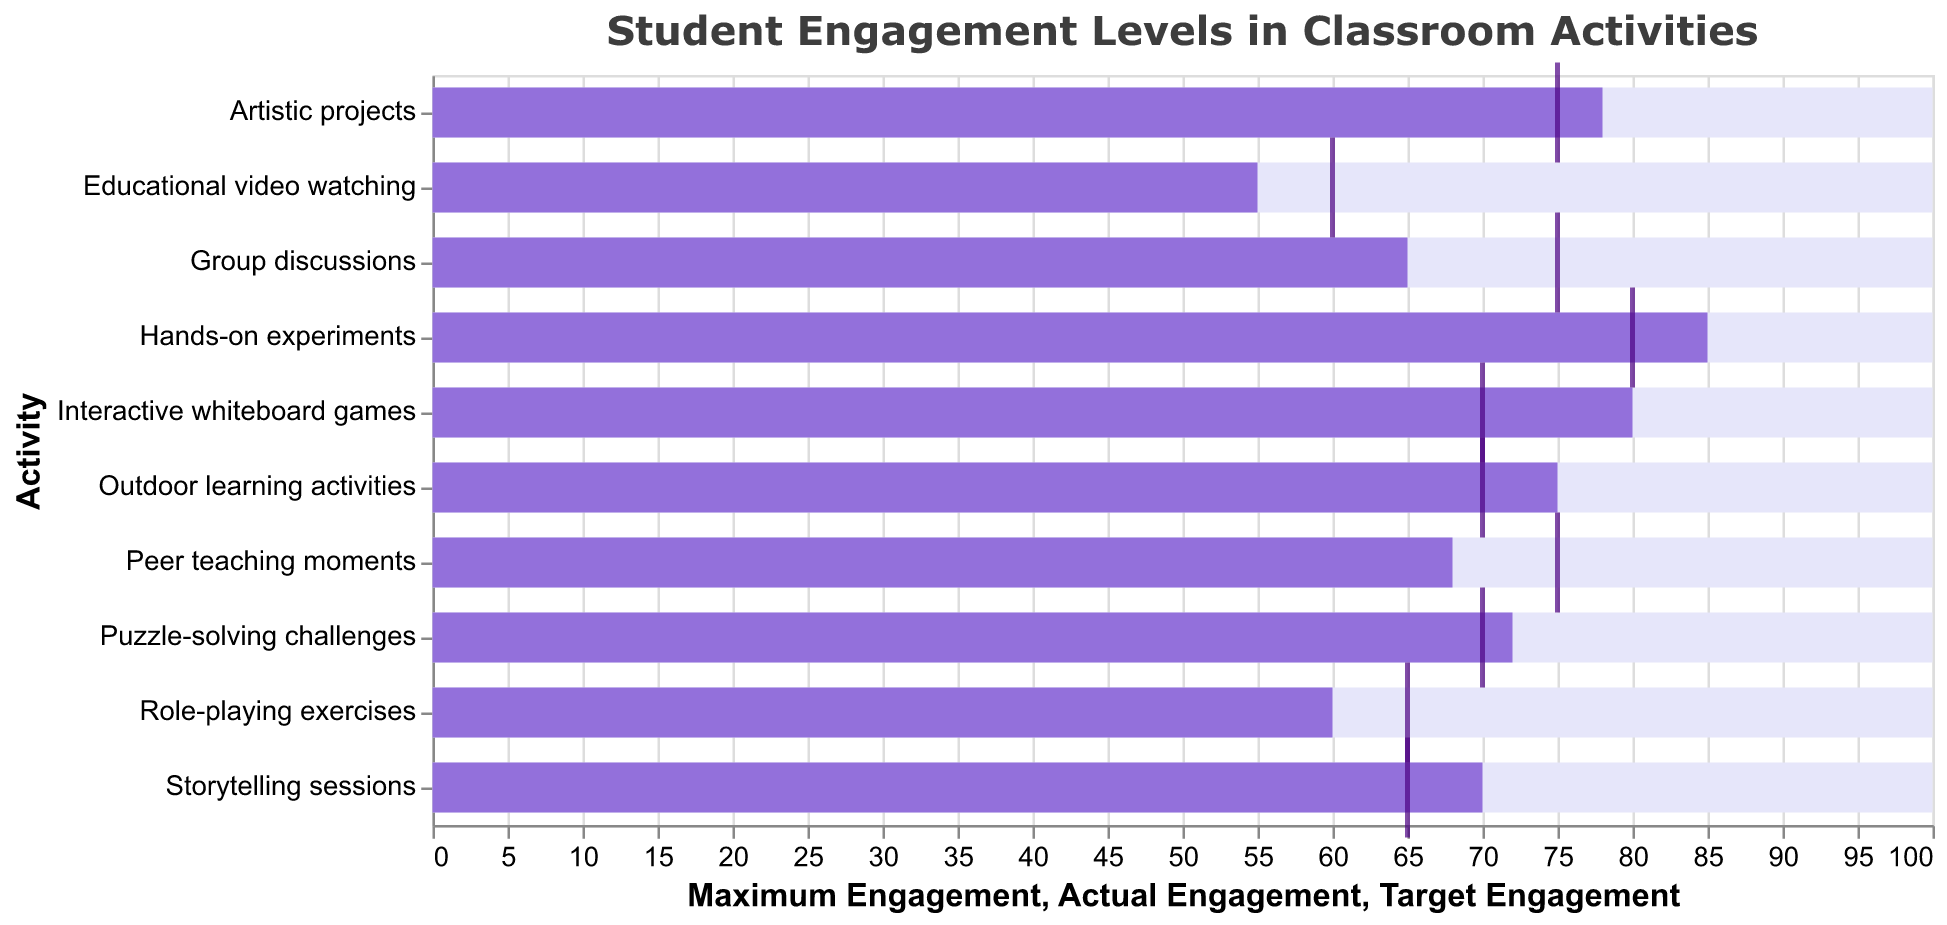What is the title of the bullet chart? The chart title is present at the top of the figure. It reads: "Student Engagement Levels in Classroom Activities".
Answer: Student Engagement Levels in Classroom Activities How many activities have an actual engagement above their target engagement? To answer this, we identify the activities where the bar representing 'Actual Engagement' exceeds the 'Target Engagement' tick mark. They are "Interactive whiteboard games," "Hands-on experiments," "Storytelling sessions," "Outdoor learning activities," "Artistic projects," and "Puzzle-solving challenges."
Answer: Six Which activity has the lowest actual engagement level? By examining the 'Actual Engagement' bar sizing for all activities, we find that "Educational video watching" has the smallest bar, indicating it has the lowest actual engagement level.
Answer: Educational video watching Is there an activity where the actual engagement exactly matches the target engagement? We need to check if any bar (Actual Engagement) is exactly aligned with its respective tick mark (Target Engagement). None of the activities have an exact match.
Answer: No What is the difference between the actual engagement and target engagement for Hands-on experiments? Subtract the Target Engagement from the Actual Engagement for "Hands-on experiments": 85 - 80 = 5.
Answer: 5 Which activities have a higher actual engagement level than "Group discussions"? We will find all activities with 'Actual Engagement' values greater than 65 (the value for "Group discussions"). They are "Interactive whiteboard games," "Hands-on experiments," "Storytelling sessions," "Outdoor learning activities," "Artistic projects," and "Puzzle-solving challenges."
Answer: Six activities What is the average actual engagement level across all activities? Sum all the 'Actual Engagement' values and then divide by the number of activities: (65 + 80 + 85 + 70 + 75 + 60 + 55 + 78 + 72 + 68) / 10 = 70.8.
Answer: 70.8 Which activity has the highest target engagement level? By looking up the lengths of the tick marks (Target Engagement), "Hands-on experiments" have the highest target engagement level of 80.
Answer: Hands-on experiments Which activity exceeds its target engagement by the largest margin? To find the largest difference between 'Actual Engagement' and 'Target Engagement,' we calculate the differences: "Interactive whiteboard games" (80-70=10), "Hands-on experiments" (85-80=5), "Storytelling sessions" (70-65=5), "Outdoor learning activities" (75-70=5), "Artistic projects" (78-75=3), and "Puzzle-solving challenges" (72-70=2). The largest margin is 10 for "Interactive whiteboard games."
Answer: Interactive whiteboard games 